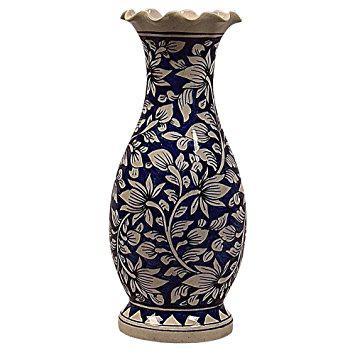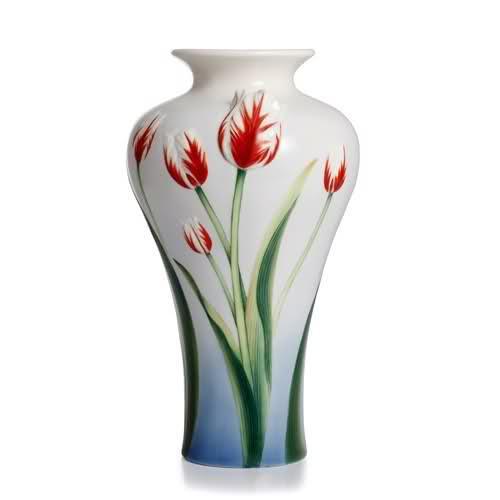The first image is the image on the left, the second image is the image on the right. Considering the images on both sides, is "The right image contains at least two flower vases." valid? Answer yes or no. No. The first image is the image on the left, the second image is the image on the right. Assess this claim about the two images: "there is a vase with at least one tulip in it". Correct or not? Answer yes or no. No. 